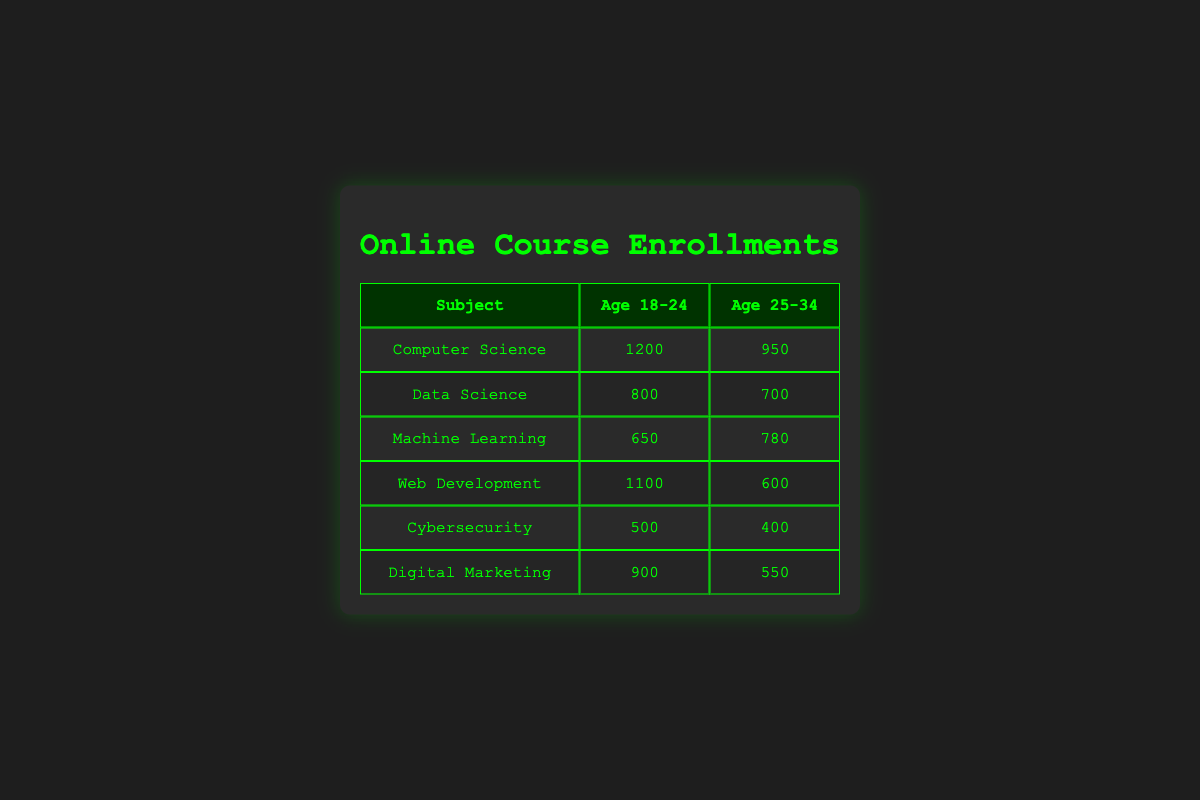What is the highest number of enrollments in the 18-24 age group? From the table, the maximum enrollments in the 18-24 age group can be found by looking at the numbers in that column. The highest value listed is 1200, which corresponds to "Computer Science."
Answer: 1200 What subject has the lowest enrollments in the 25-34 age group? To find the subject with the lowest enrollments in the 25-34 age group, we check the values in that column. The lowest value is 400, which is for "Cybersecurity."
Answer: Cybersecurity What are the total enrollments for the "Data Science" subject across both age groups? The enrollments for "Data Science" are 800 in the 18-24 age group and 700 in the 25-34 age group. Summing these values gives 800 + 700 = 1500.
Answer: 1500 Is the enrollment for "Machine Learning" higher in the 25-34 age group than in the 18-24 age group? Looking at the enrollments, "Machine Learning" has 650 in the 18-24 age group and 780 in the 25-34 age group. Since 780 is greater than 650, the statement is true.
Answer: Yes What is the average number of enrollments for the 18-24 age group across all subjects? To calculate the average for the 18-24 age group, we first sum the enrollments: 1200 + 800 + 650 + 1100 + 500 + 900 = 4150. There are 6 subjects, so the average is 4150 / 6 = 691.67.
Answer: 691.67 Which subject has the largest difference between age groups in enrollments? To find the largest difference, we calculate the differences for each subject: for Computer Science (1200 - 950 = 250), Data Science (800 - 700 = 100), Machine Learning (650 - 780 = -130), Web Development (1100 - 600 = 500), Cybersecurity (500 - 400 = 100), Digital Marketing (900 - 550 = 350). The largest difference is for Web Development, which is 500.
Answer: Web Development Is the total enrollment for those aged 18-24 greater than the total enrollment for those aged 25-34? The total for the 18-24 age group is 4150, while for the 25-34 age group it is 3970 (950 + 700 + 780 + 600 + 400 + 550 = 3970). Since 4150 is greater than 3970, the statement is true.
Answer: Yes Which age group has more overall enrollments when all subjects are considered? We previously calculated the totals for both age groups: 4150 for 18-24 and 3970 for 25-34. The 18-24 age group has more overall enrollments.
Answer: 18-24 